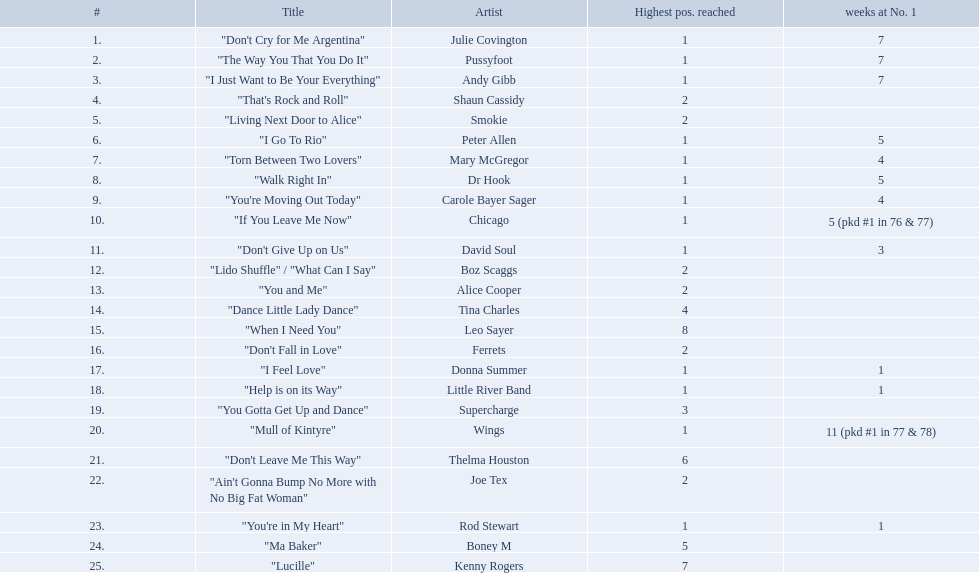How long is the longest amount of time spent at number 1? 11 (pkd #1 in 77 & 78). What song spent 11 weeks at number 1? "Mull of Kintyre". What band had a number 1 hit with this song? Wings. Write the full table. {'header': ['#', 'Title', 'Artist', 'Highest pos. reached', 'weeks at No. 1'], 'rows': [['1.', '"Don\'t Cry for Me Argentina"', 'Julie Covington', '1', '7'], ['2.', '"The Way You That You Do It"', 'Pussyfoot', '1', '7'], ['3.', '"I Just Want to Be Your Everything"', 'Andy Gibb', '1', '7'], ['4.', '"That\'s Rock and Roll"', 'Shaun Cassidy', '2', ''], ['5.', '"Living Next Door to Alice"', 'Smokie', '2', ''], ['6.', '"I Go To Rio"', 'Peter Allen', '1', '5'], ['7.', '"Torn Between Two Lovers"', 'Mary McGregor', '1', '4'], ['8.', '"Walk Right In"', 'Dr Hook', '1', '5'], ['9.', '"You\'re Moving Out Today"', 'Carole Bayer Sager', '1', '4'], ['10.', '"If You Leave Me Now"', 'Chicago', '1', '5 (pkd #1 in 76 & 77)'], ['11.', '"Don\'t Give Up on Us"', 'David Soul', '1', '3'], ['12.', '"Lido Shuffle" / "What Can I Say"', 'Boz Scaggs', '2', ''], ['13.', '"You and Me"', 'Alice Cooper', '2', ''], ['14.', '"Dance Little Lady Dance"', 'Tina Charles', '4', ''], ['15.', '"When I Need You"', 'Leo Sayer', '8', ''], ['16.', '"Don\'t Fall in Love"', 'Ferrets', '2', ''], ['17.', '"I Feel Love"', 'Donna Summer', '1', '1'], ['18.', '"Help is on its Way"', 'Little River Band', '1', '1'], ['19.', '"You Gotta Get Up and Dance"', 'Supercharge', '3', ''], ['20.', '"Mull of Kintyre"', 'Wings', '1', '11 (pkd #1 in 77 & 78)'], ['21.', '"Don\'t Leave Me This Way"', 'Thelma Houston', '6', ''], ['22.', '"Ain\'t Gonna Bump No More with No Big Fat Woman"', 'Joe Tex', '2', ''], ['23.', '"You\'re in My Heart"', 'Rod Stewart', '1', '1'], ['24.', '"Ma Baker"', 'Boney M', '5', ''], ['25.', '"Lucille"', 'Kenny Rogers', '7', '']]} Which artists were included in the top 25 singles for 1977 in australia? Julie Covington, Pussyfoot, Andy Gibb, Shaun Cassidy, Smokie, Peter Allen, Mary McGregor, Dr Hook, Carole Bayer Sager, Chicago, David Soul, Boz Scaggs, Alice Cooper, Tina Charles, Leo Sayer, Ferrets, Donna Summer, Little River Band, Supercharge, Wings, Thelma Houston, Joe Tex, Rod Stewart, Boney M, Kenny Rogers. And for how many weeks did they chart at number 1? 7, 7, 7, , , 5, 4, 5, 4, 5 (pkd #1 in 76 & 77), 3, , , , , , 1, 1, , 11 (pkd #1 in 77 & 78), , , 1, , . Which artist was in the number 1 spot for most time? Wings. Who had one of the briefest periods at the number one spot? Rod Stewart. Who had no time at the peak position? Shaun Cassidy. Who had the greatest number of weeks as the top-ranked? Wings. What is the longest period a song has held the number 1 spot? 11 (pkd #1 in 77 & 78). Which track was at number 1 for 11 weeks? "Mull of Kintyre". What band had a chart-topping hit with this song? Wings. 